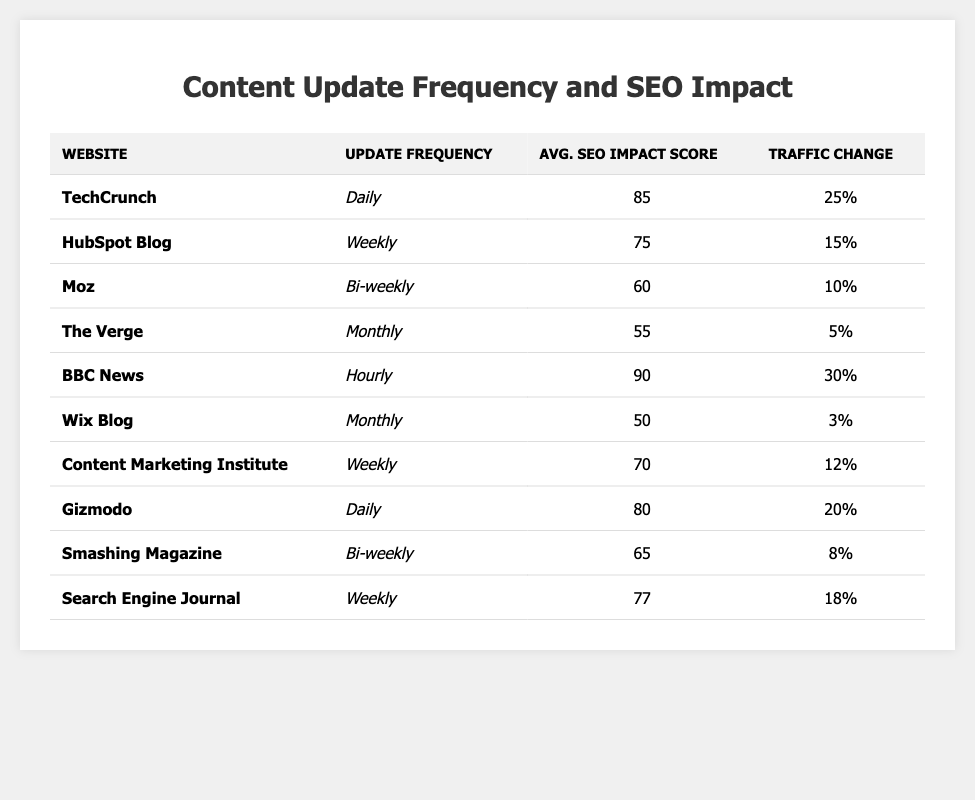What is the website with the highest average SEO impact score? By reviewing the table, the website with the highest average SEO impact score is BBC News, which has a score of 90.
Answer: BBC News Which website updates its content weekly and has a traffic change percentage of 15%? Looking through the table, HubSpot Blog updates its content weekly and has a traffic change percentage of 15%.
Answer: HubSpot Blog What is the traffic change percentage for Gizmodo? The traffic change percentage for Gizmodo, as listed in the table, is 20%.
Answer: 20% How many websites have a monthly update frequency? Counting the entries in the table, there are three websites with a monthly update frequency: The Verge, Wix Blog, and each has distinct SEO impact scores and traffic change percentages.
Answer: 3 Which update frequency is associated with the lowest average SEO impact score? Glancing at the table, the update frequency that corresponds to the lowest average SEO impact score of 50 is "Monthly," which is for Wix Blog.
Answer: Monthly What is the difference between the average SEO impact scores of daily and bi-weekly update frequencies? Examining the scores, the average SEO impact score for websites updating daily (TechCrunch and Gizmodo) is (85 + 80) / 2 = 82.5, while for bi-weekly (Moz and Smashing Magazine), it is (60 + 65) / 2 = 62.5. The difference is then 82.5 - 62.5 = 20.
Answer: 20 Which website experiences the most significant traffic change percentage among all those listed? Comparing the traffic change percentages in the table, BBC News has the highest percentage at 30%.
Answer: 30 Is it true that all websites that update content daily have higher SEO impact scores than those that update monthly? Evaluating the table, it shows that TechCrunch (85) and Gizmodo (80) do indeed have higher scores than The Verge (55) and Wix Blog (50), confirming this statement to be true.
Answer: Yes What is the average traffic change percentage for websites that update content weekly? The weekly updating websites are HubSpot Blog (15), Content Marketing Institute (12), and Search Engine Journal (18). Their average is (15 + 12 + 18) / 3 = 15.
Answer: 15 Which update frequency is most common based on the data presented? Scanning the table, the most common update frequency is "Weekly," with a total of three entries from HubSpot Blog, Content Marketing Institute, and Search Engine Journal.
Answer: Weekly 